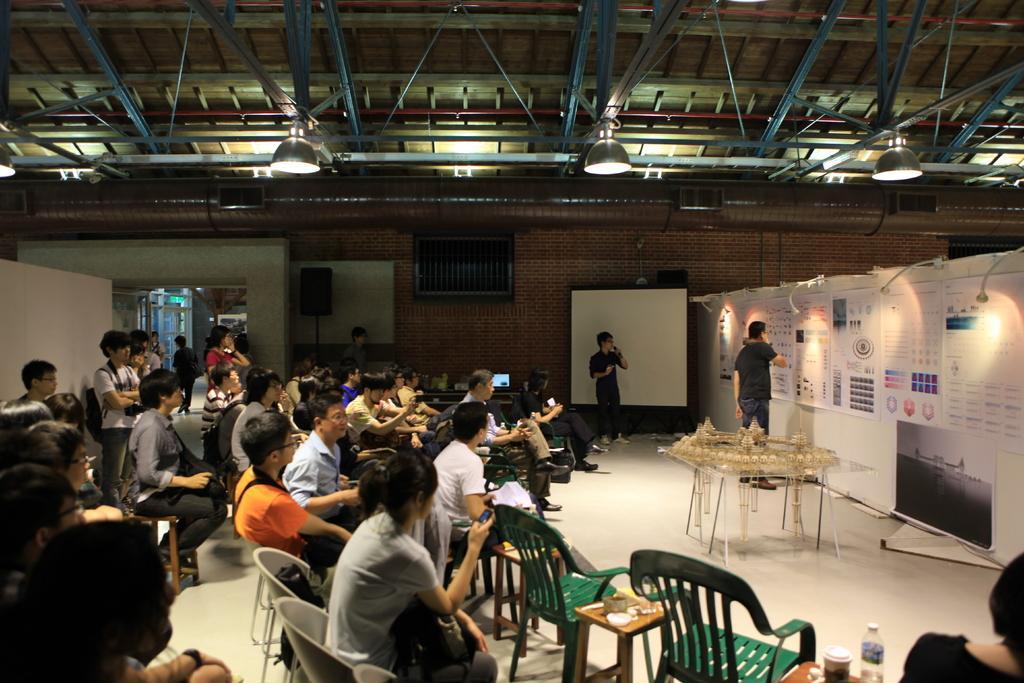How would you summarize this image in a sentence or two? There are group of people sitting on the chairs. These are the charts attached to the wall. This is a table with some object placed on it. There are few people standing. This looks like a speaker. These are the lamps attached to the rooftop. This looks like a whiteboard. 